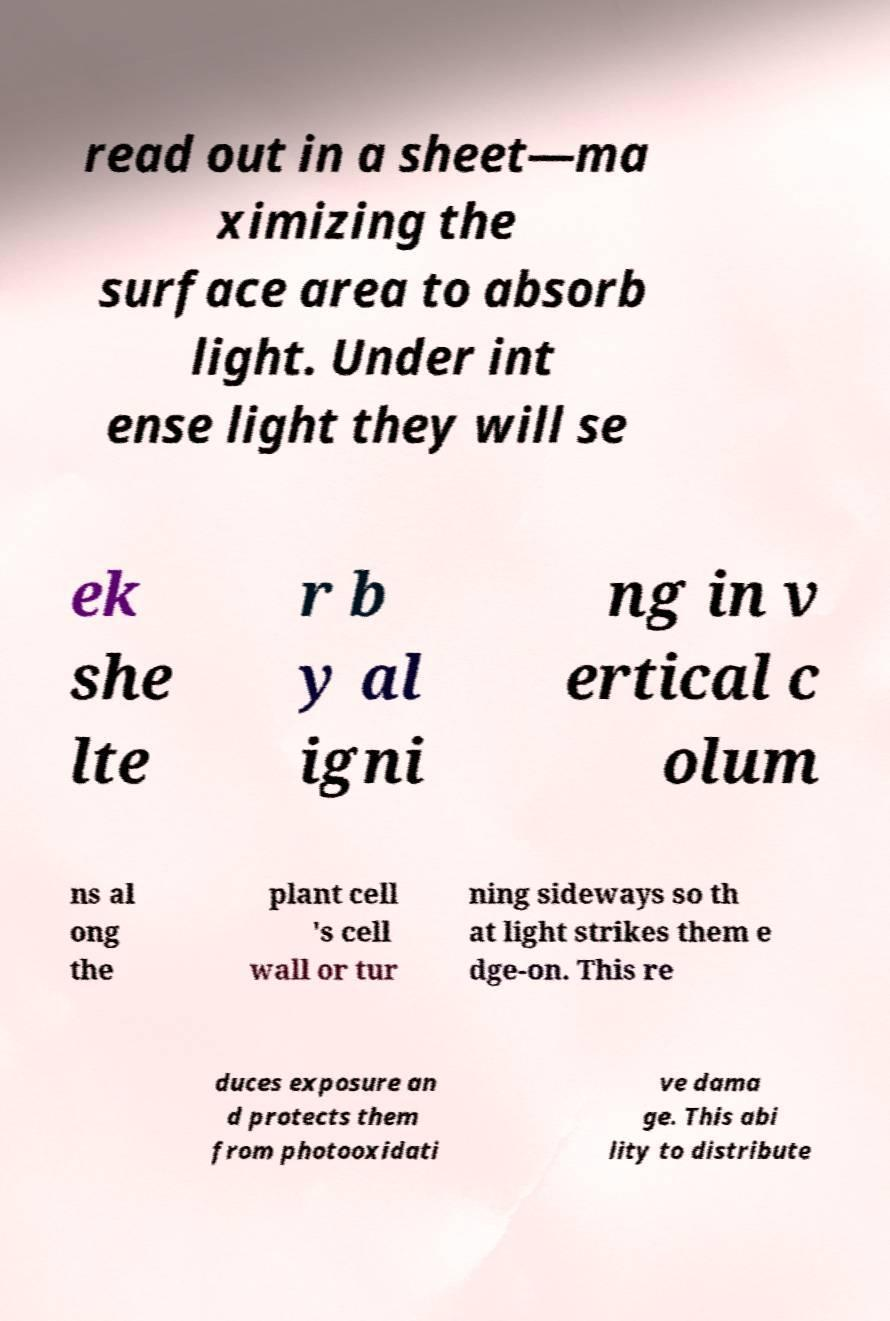Please read and relay the text visible in this image. What does it say? read out in a sheet—ma ximizing the surface area to absorb light. Under int ense light they will se ek she lte r b y al igni ng in v ertical c olum ns al ong the plant cell 's cell wall or tur ning sideways so th at light strikes them e dge-on. This re duces exposure an d protects them from photooxidati ve dama ge. This abi lity to distribute 